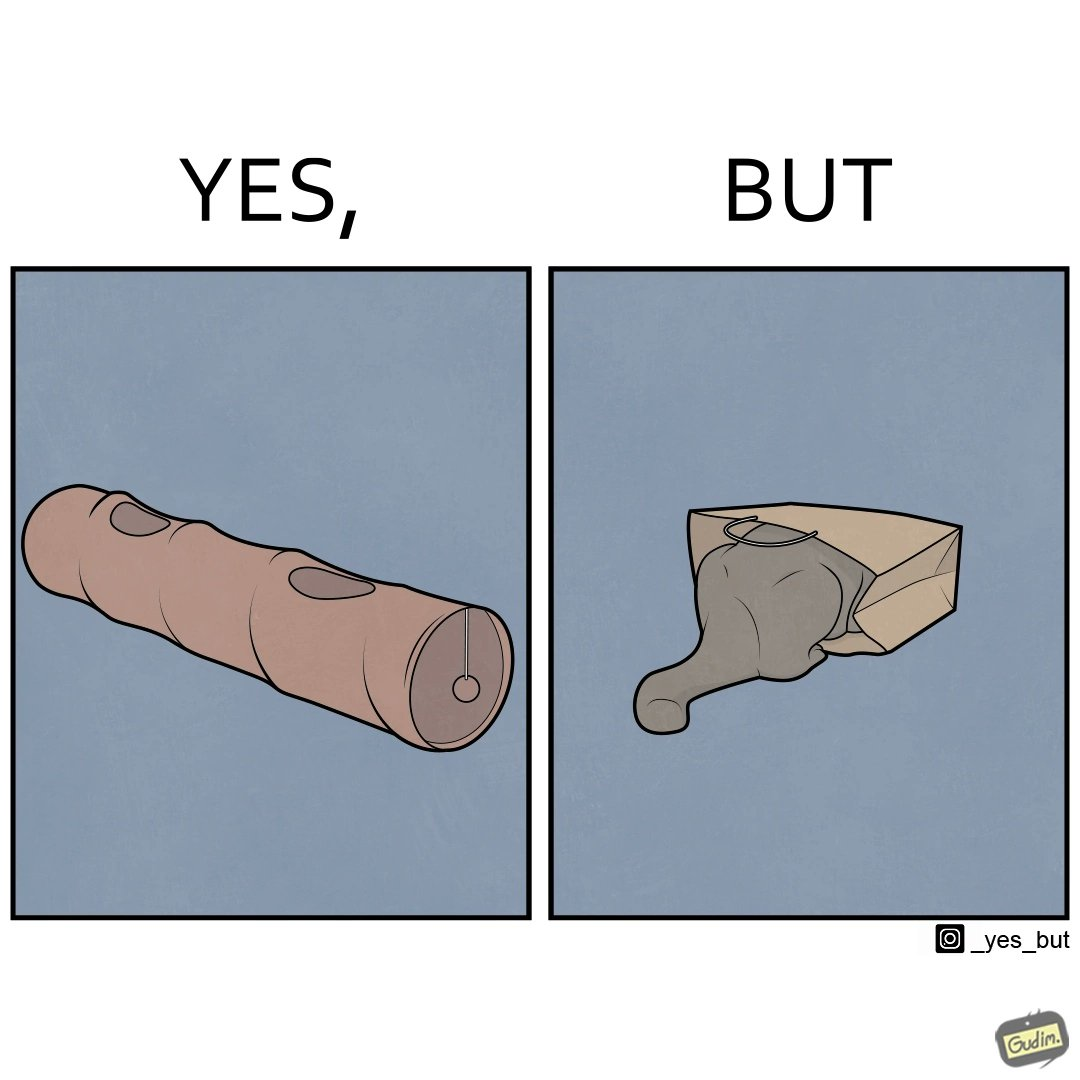Would you classify this image as satirical? Yes, this image is satirical. 